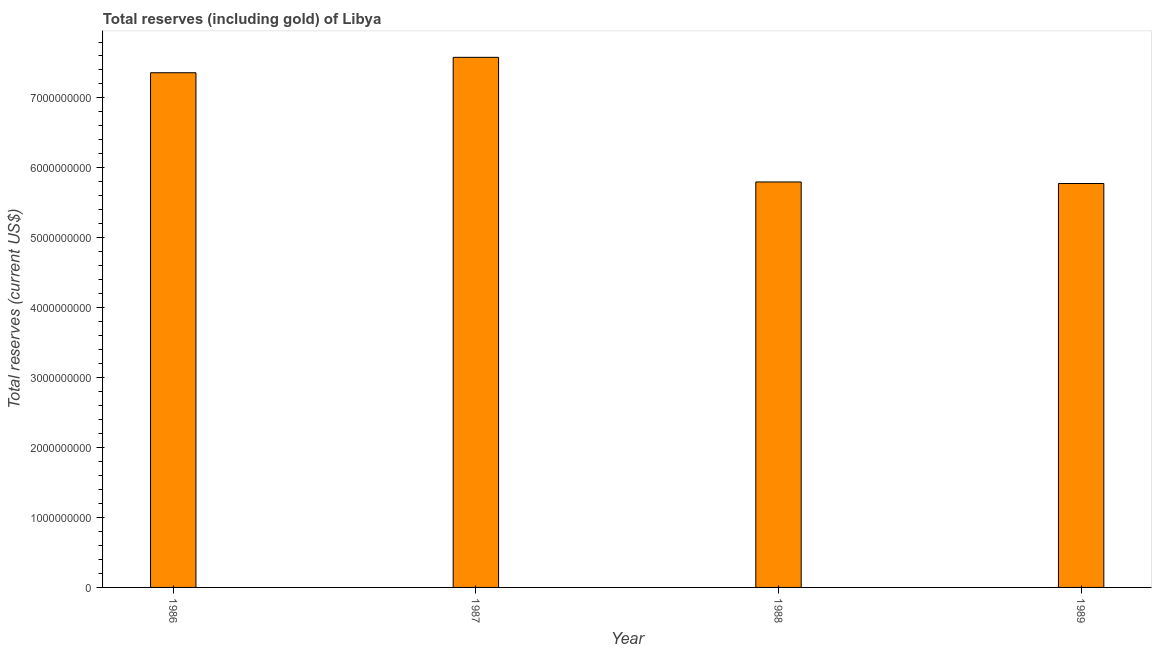Does the graph contain any zero values?
Give a very brief answer. No. What is the title of the graph?
Provide a succinct answer. Total reserves (including gold) of Libya. What is the label or title of the X-axis?
Keep it short and to the point. Year. What is the label or title of the Y-axis?
Offer a very short reply. Total reserves (current US$). What is the total reserves (including gold) in 1987?
Provide a succinct answer. 7.58e+09. Across all years, what is the maximum total reserves (including gold)?
Provide a short and direct response. 7.58e+09. Across all years, what is the minimum total reserves (including gold)?
Keep it short and to the point. 5.78e+09. What is the sum of the total reserves (including gold)?
Your response must be concise. 2.65e+1. What is the difference between the total reserves (including gold) in 1988 and 1989?
Provide a succinct answer. 2.22e+07. What is the average total reserves (including gold) per year?
Provide a succinct answer. 6.63e+09. What is the median total reserves (including gold)?
Offer a very short reply. 6.58e+09. In how many years, is the total reserves (including gold) greater than 1000000000 US$?
Give a very brief answer. 4. Do a majority of the years between 1987 and 1989 (inclusive) have total reserves (including gold) greater than 1800000000 US$?
Your answer should be very brief. Yes. What is the ratio of the total reserves (including gold) in 1986 to that in 1989?
Offer a very short reply. 1.27. Is the total reserves (including gold) in 1988 less than that in 1989?
Keep it short and to the point. No. Is the difference between the total reserves (including gold) in 1986 and 1988 greater than the difference between any two years?
Provide a succinct answer. No. What is the difference between the highest and the second highest total reserves (including gold)?
Your response must be concise. 2.20e+08. What is the difference between the highest and the lowest total reserves (including gold)?
Give a very brief answer. 1.80e+09. In how many years, is the total reserves (including gold) greater than the average total reserves (including gold) taken over all years?
Your answer should be compact. 2. What is the difference between two consecutive major ticks on the Y-axis?
Give a very brief answer. 1.00e+09. What is the Total reserves (current US$) in 1986?
Provide a short and direct response. 7.36e+09. What is the Total reserves (current US$) of 1987?
Provide a succinct answer. 7.58e+09. What is the Total reserves (current US$) in 1988?
Offer a very short reply. 5.80e+09. What is the Total reserves (current US$) in 1989?
Provide a short and direct response. 5.78e+09. What is the difference between the Total reserves (current US$) in 1986 and 1987?
Give a very brief answer. -2.20e+08. What is the difference between the Total reserves (current US$) in 1986 and 1988?
Your response must be concise. 1.56e+09. What is the difference between the Total reserves (current US$) in 1986 and 1989?
Offer a very short reply. 1.58e+09. What is the difference between the Total reserves (current US$) in 1987 and 1988?
Provide a succinct answer. 1.78e+09. What is the difference between the Total reserves (current US$) in 1987 and 1989?
Your answer should be very brief. 1.80e+09. What is the difference between the Total reserves (current US$) in 1988 and 1989?
Your response must be concise. 2.22e+07. What is the ratio of the Total reserves (current US$) in 1986 to that in 1988?
Give a very brief answer. 1.27. What is the ratio of the Total reserves (current US$) in 1986 to that in 1989?
Make the answer very short. 1.27. What is the ratio of the Total reserves (current US$) in 1987 to that in 1988?
Provide a short and direct response. 1.31. What is the ratio of the Total reserves (current US$) in 1987 to that in 1989?
Make the answer very short. 1.31. What is the ratio of the Total reserves (current US$) in 1988 to that in 1989?
Provide a succinct answer. 1. 